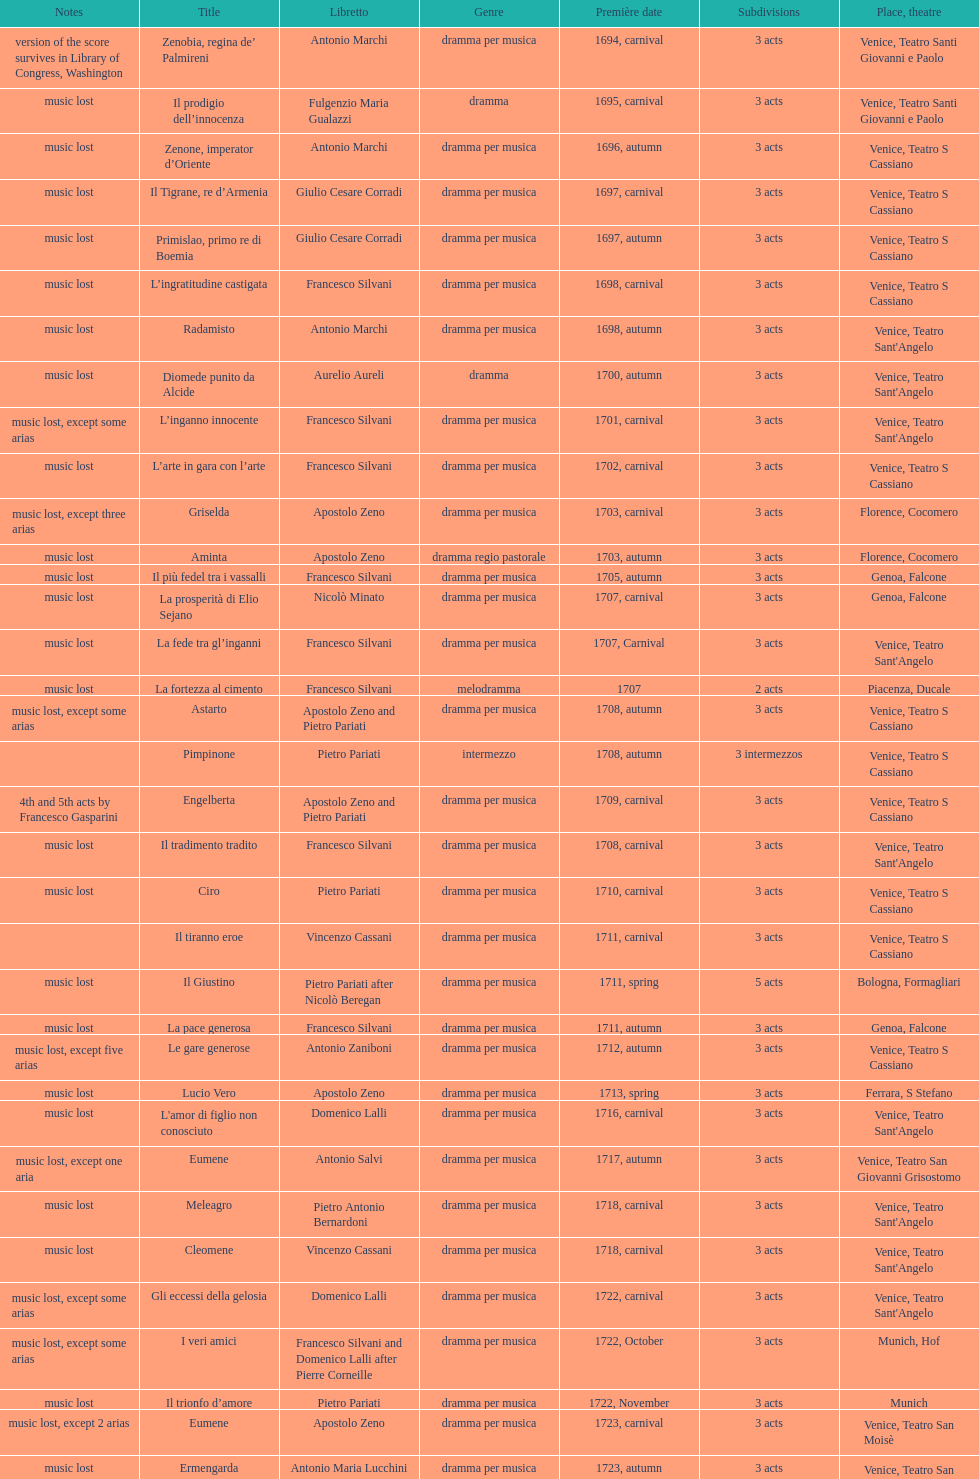How many were released after zenone, imperator d'oriente? 52. 